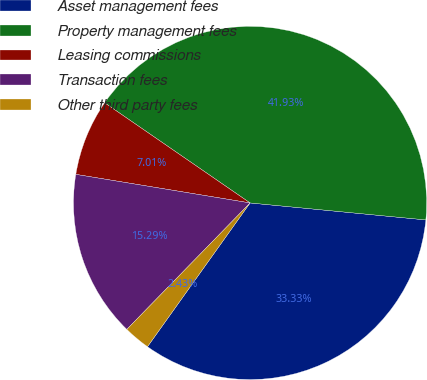Convert chart. <chart><loc_0><loc_0><loc_500><loc_500><pie_chart><fcel>Asset management fees<fcel>Property management fees<fcel>Leasing commissions<fcel>Transaction fees<fcel>Other third party fees<nl><fcel>33.33%<fcel>41.93%<fcel>7.01%<fcel>15.29%<fcel>2.43%<nl></chart> 